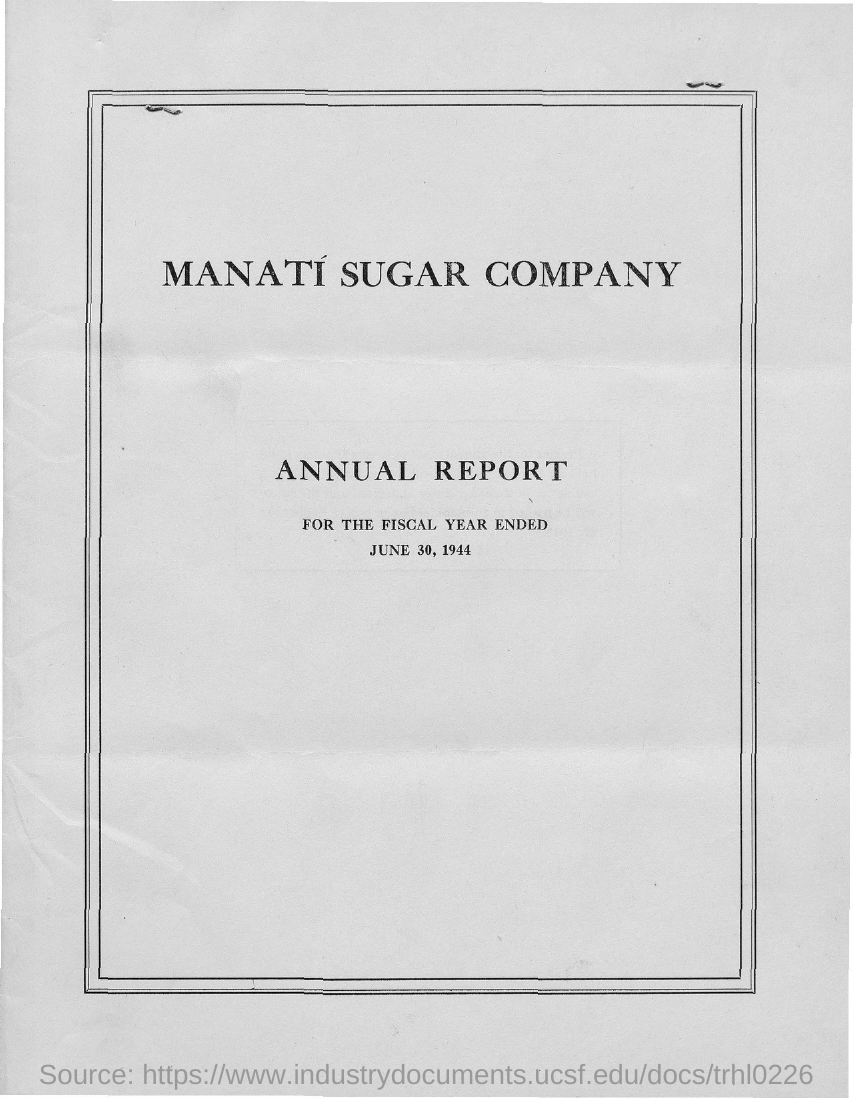What is the company name?
Ensure brevity in your answer.  Manati sugar comapny. What is the date mentioned in the document?
Make the answer very short. June 30, 1944. 